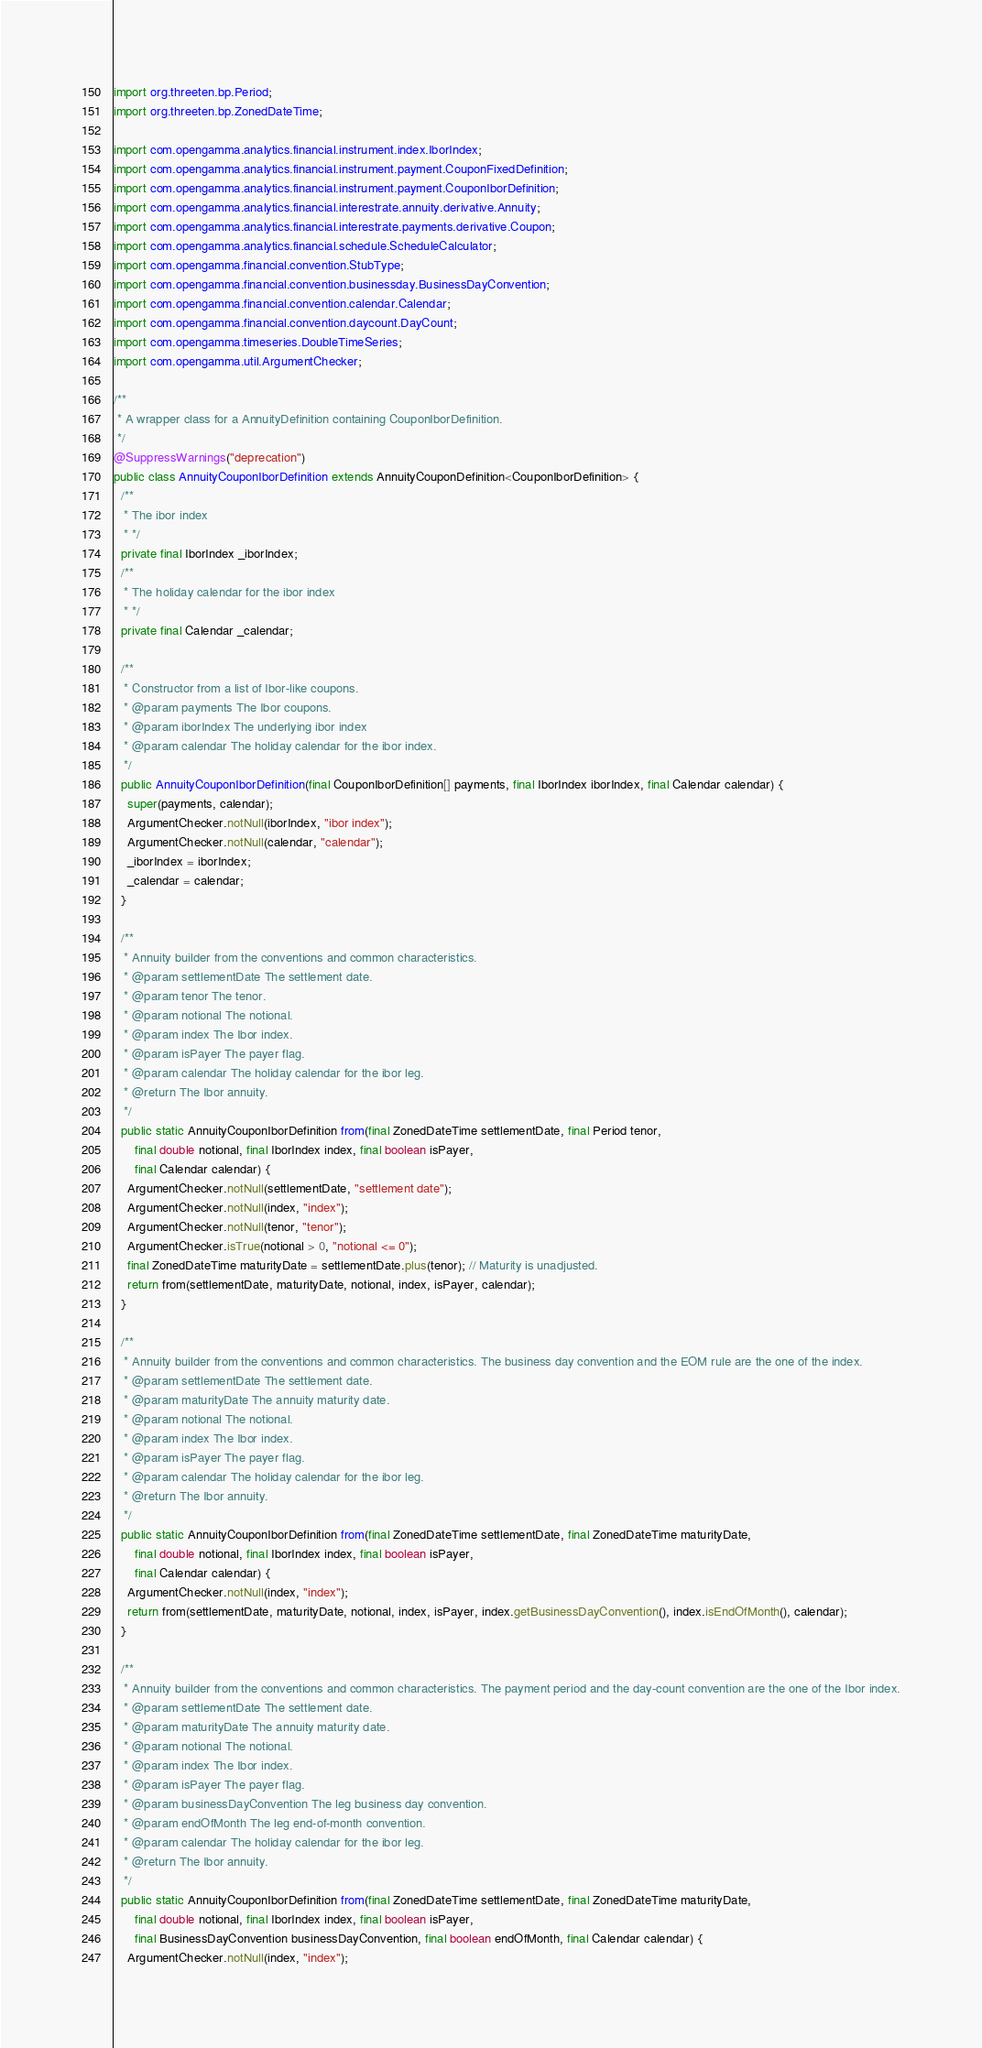<code> <loc_0><loc_0><loc_500><loc_500><_Java_>import org.threeten.bp.Period;
import org.threeten.bp.ZonedDateTime;

import com.opengamma.analytics.financial.instrument.index.IborIndex;
import com.opengamma.analytics.financial.instrument.payment.CouponFixedDefinition;
import com.opengamma.analytics.financial.instrument.payment.CouponIborDefinition;
import com.opengamma.analytics.financial.interestrate.annuity.derivative.Annuity;
import com.opengamma.analytics.financial.interestrate.payments.derivative.Coupon;
import com.opengamma.analytics.financial.schedule.ScheduleCalculator;
import com.opengamma.financial.convention.StubType;
import com.opengamma.financial.convention.businessday.BusinessDayConvention;
import com.opengamma.financial.convention.calendar.Calendar;
import com.opengamma.financial.convention.daycount.DayCount;
import com.opengamma.timeseries.DoubleTimeSeries;
import com.opengamma.util.ArgumentChecker;

/**
 * A wrapper class for a AnnuityDefinition containing CouponIborDefinition.
 */
@SuppressWarnings("deprecation")
public class AnnuityCouponIborDefinition extends AnnuityCouponDefinition<CouponIborDefinition> {
  /**
   * The ibor index
   * */
  private final IborIndex _iborIndex;
  /**
   * The holiday calendar for the ibor index
   * */
  private final Calendar _calendar;

  /**
   * Constructor from a list of Ibor-like coupons.
   * @param payments The Ibor coupons.
   * @param iborIndex The underlying ibor index
   * @param calendar The holiday calendar for the ibor index.
   */
  public AnnuityCouponIborDefinition(final CouponIborDefinition[] payments, final IborIndex iborIndex, final Calendar calendar) {
    super(payments, calendar);
    ArgumentChecker.notNull(iborIndex, "ibor index");
    ArgumentChecker.notNull(calendar, "calendar");
    _iborIndex = iborIndex;
    _calendar = calendar;
  }

  /**
   * Annuity builder from the conventions and common characteristics.
   * @param settlementDate The settlement date.
   * @param tenor The tenor.
   * @param notional The notional.
   * @param index The Ibor index.
   * @param isPayer The payer flag.
   * @param calendar The holiday calendar for the ibor leg.
   * @return The Ibor annuity.
   */
  public static AnnuityCouponIborDefinition from(final ZonedDateTime settlementDate, final Period tenor,
      final double notional, final IborIndex index, final boolean isPayer,
      final Calendar calendar) {
    ArgumentChecker.notNull(settlementDate, "settlement date");
    ArgumentChecker.notNull(index, "index");
    ArgumentChecker.notNull(tenor, "tenor");
    ArgumentChecker.isTrue(notional > 0, "notional <= 0");
    final ZonedDateTime maturityDate = settlementDate.plus(tenor); // Maturity is unadjusted.
    return from(settlementDate, maturityDate, notional, index, isPayer, calendar);
  }

  /**
   * Annuity builder from the conventions and common characteristics. The business day convention and the EOM rule are the one of the index.
   * @param settlementDate The settlement date.
   * @param maturityDate The annuity maturity date.
   * @param notional The notional.
   * @param index The Ibor index.
   * @param isPayer The payer flag.
   * @param calendar The holiday calendar for the ibor leg.
   * @return The Ibor annuity.
   */
  public static AnnuityCouponIborDefinition from(final ZonedDateTime settlementDate, final ZonedDateTime maturityDate,
      final double notional, final IborIndex index, final boolean isPayer,
      final Calendar calendar) {
    ArgumentChecker.notNull(index, "index");
    return from(settlementDate, maturityDate, notional, index, isPayer, index.getBusinessDayConvention(), index.isEndOfMonth(), calendar);
  }

  /**
   * Annuity builder from the conventions and common characteristics. The payment period and the day-count convention are the one of the Ibor index.
   * @param settlementDate The settlement date.
   * @param maturityDate The annuity maturity date.
   * @param notional The notional.
   * @param index The Ibor index.
   * @param isPayer The payer flag.
   * @param businessDayConvention The leg business day convention.
   * @param endOfMonth The leg end-of-month convention.
   * @param calendar The holiday calendar for the ibor leg.
   * @return The Ibor annuity.
   */
  public static AnnuityCouponIborDefinition from(final ZonedDateTime settlementDate, final ZonedDateTime maturityDate,
      final double notional, final IborIndex index, final boolean isPayer,
      final BusinessDayConvention businessDayConvention, final boolean endOfMonth, final Calendar calendar) {
    ArgumentChecker.notNull(index, "index");</code> 